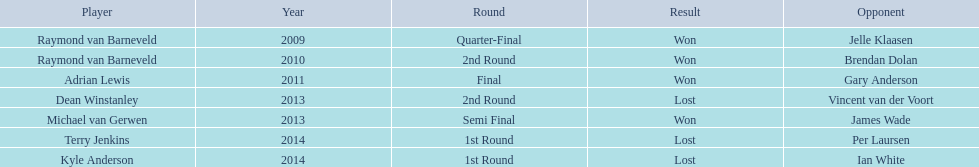Who are the players at the pdc world darts championship? Raymond van Barneveld, Raymond van Barneveld, Adrian Lewis, Dean Winstanley, Michael van Gerwen, Terry Jenkins, Kyle Anderson. When did kyle anderson lose? 2014. Which other players lost in 2014? Terry Jenkins. Who were all the athletes? Raymond van Barneveld, Raymond van Barneveld, Adrian Lewis, Dean Winstanley, Michael van Gerwen, Terry Jenkins, Kyle Anderson. Which among these competed in 2014? Terry Jenkins, Kyle Anderson. Who were their rivals? Per Laursen, Ian White. Which of these overcame terry jenkins? Per Laursen. 